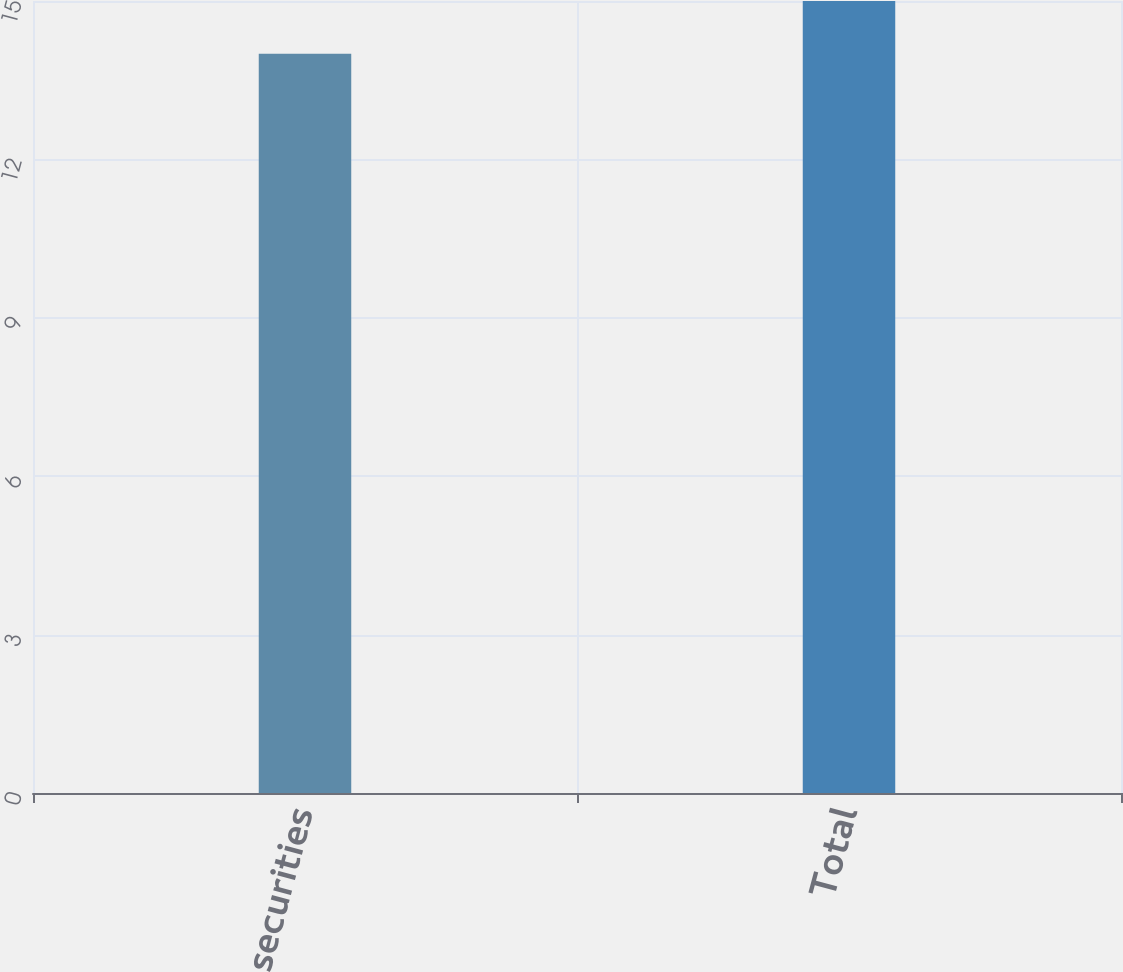Convert chart to OTSL. <chart><loc_0><loc_0><loc_500><loc_500><bar_chart><fcel>Equity securities<fcel>Total<nl><fcel>14<fcel>15<nl></chart> 